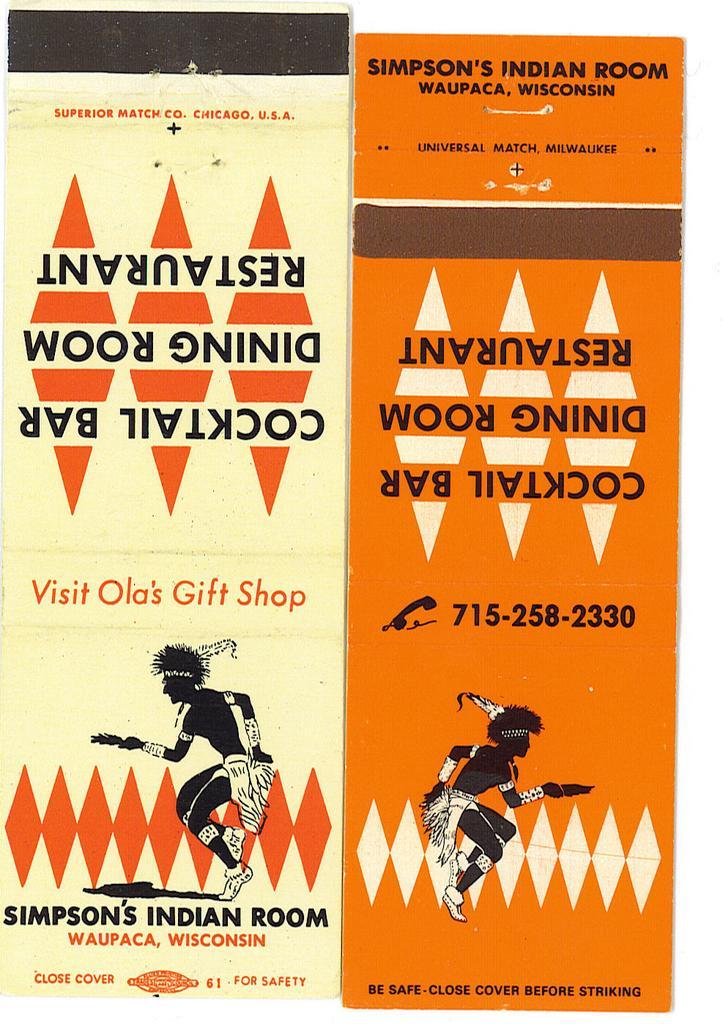Please provide a concise description of this image. In this picture we can see posters and on these posters we can see two people and some text. 